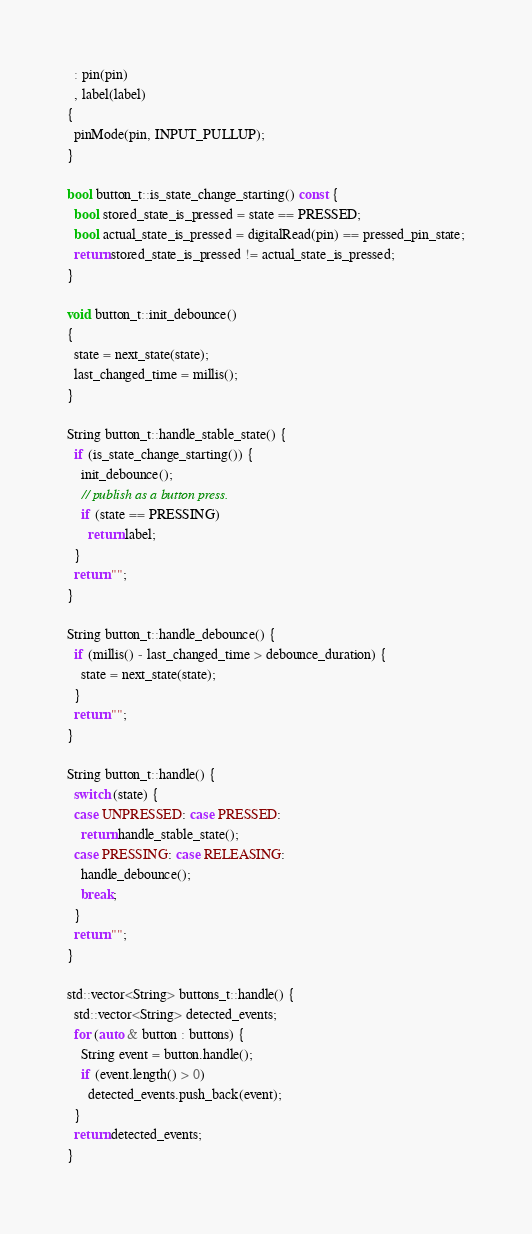<code> <loc_0><loc_0><loc_500><loc_500><_C++_>  : pin(pin)
  , label(label)
{
  pinMode(pin, INPUT_PULLUP);
}

bool button_t::is_state_change_starting() const {
  bool stored_state_is_pressed = state == PRESSED;
  bool actual_state_is_pressed = digitalRead(pin) == pressed_pin_state;
  return stored_state_is_pressed != actual_state_is_pressed;
}

void button_t::init_debounce()
{
  state = next_state(state);
  last_changed_time = millis();
}

String button_t::handle_stable_state() {
  if (is_state_change_starting()) {
    init_debounce();
    // publish as a button press.
    if (state == PRESSING) 
      return label;
  }
  return "";
}

String button_t::handle_debounce() {
  if (millis() - last_changed_time > debounce_duration) {
    state = next_state(state);
  }
  return "";
}

String button_t::handle() {
  switch (state) {
  case UNPRESSED: case PRESSED:
    return handle_stable_state();
  case PRESSING: case RELEASING:
    handle_debounce();
    break;
  }
  return "";
}

std::vector<String> buttons_t::handle() {
  std::vector<String> detected_events;
  for (auto & button : buttons) {
    String event = button.handle();
    if (event.length() > 0)
      detected_events.push_back(event);
  }
  return detected_events;
}
</code> 